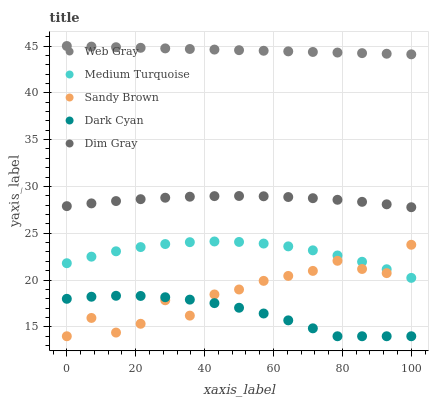Does Dark Cyan have the minimum area under the curve?
Answer yes or no. Yes. Does Web Gray have the maximum area under the curve?
Answer yes or no. Yes. Does Dim Gray have the minimum area under the curve?
Answer yes or no. No. Does Dim Gray have the maximum area under the curve?
Answer yes or no. No. Is Web Gray the smoothest?
Answer yes or no. Yes. Is Sandy Brown the roughest?
Answer yes or no. Yes. Is Dim Gray the smoothest?
Answer yes or no. No. Is Dim Gray the roughest?
Answer yes or no. No. Does Dark Cyan have the lowest value?
Answer yes or no. Yes. Does Dim Gray have the lowest value?
Answer yes or no. No. Does Web Gray have the highest value?
Answer yes or no. Yes. Does Dim Gray have the highest value?
Answer yes or no. No. Is Dim Gray less than Web Gray?
Answer yes or no. Yes. Is Web Gray greater than Dark Cyan?
Answer yes or no. Yes. Does Sandy Brown intersect Medium Turquoise?
Answer yes or no. Yes. Is Sandy Brown less than Medium Turquoise?
Answer yes or no. No. Is Sandy Brown greater than Medium Turquoise?
Answer yes or no. No. Does Dim Gray intersect Web Gray?
Answer yes or no. No. 